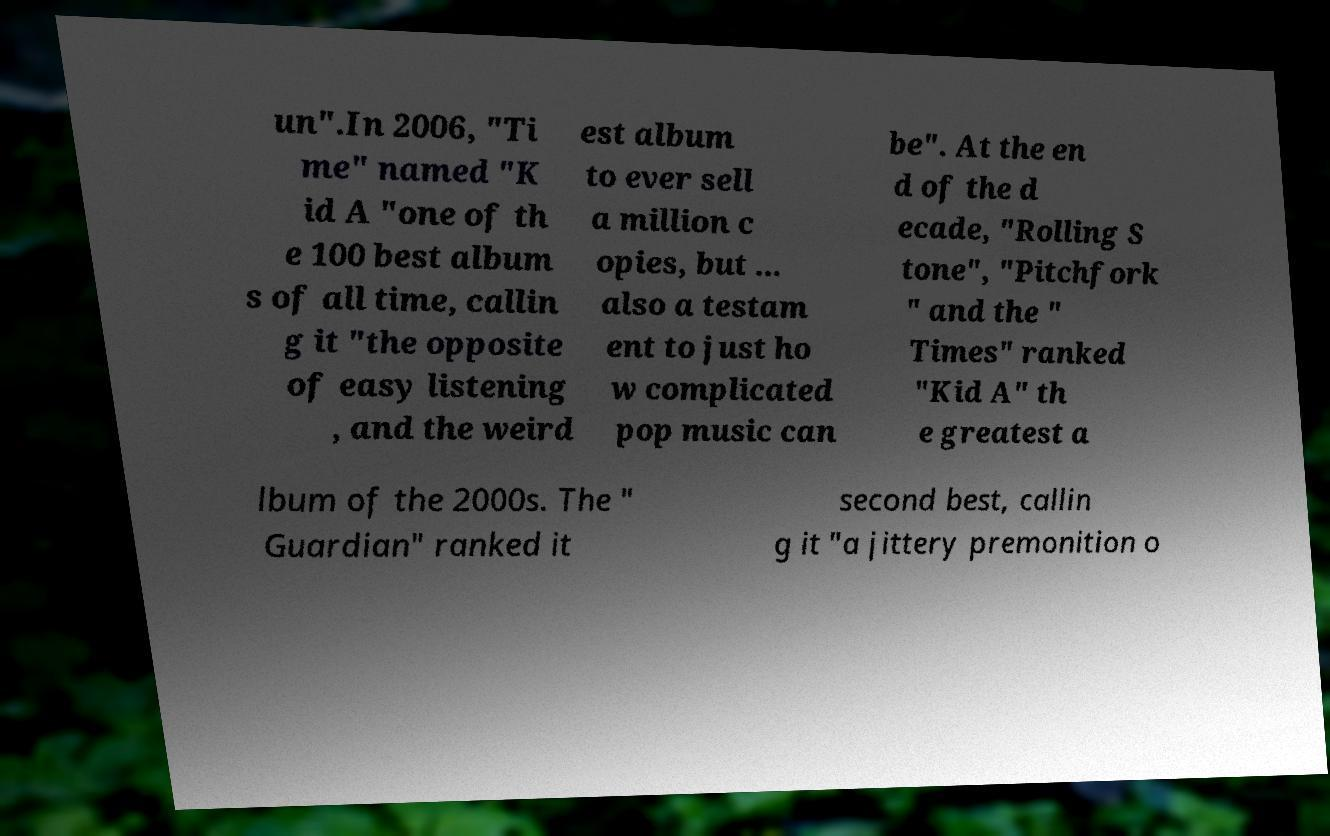What messages or text are displayed in this image? I need them in a readable, typed format. un".In 2006, "Ti me" named "K id A "one of th e 100 best album s of all time, callin g it "the opposite of easy listening , and the weird est album to ever sell a million c opies, but ... also a testam ent to just ho w complicated pop music can be". At the en d of the d ecade, "Rolling S tone", "Pitchfork " and the " Times" ranked "Kid A" th e greatest a lbum of the 2000s. The " Guardian" ranked it second best, callin g it "a jittery premonition o 